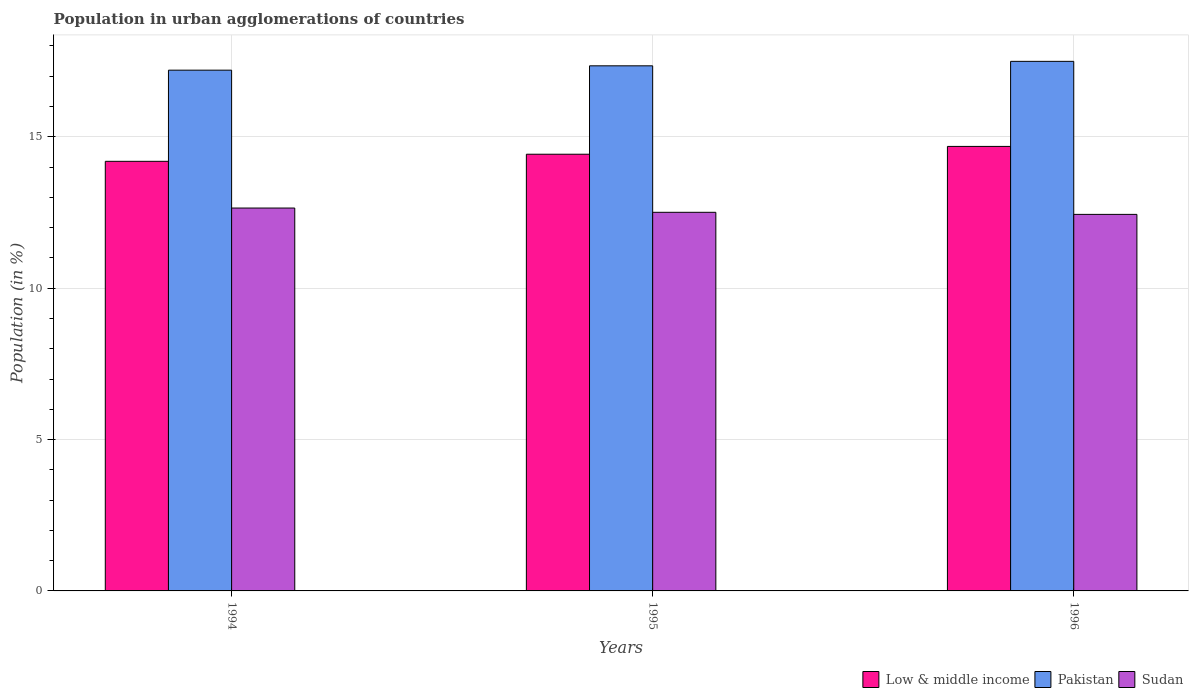How many different coloured bars are there?
Your response must be concise. 3. How many groups of bars are there?
Your answer should be compact. 3. Are the number of bars per tick equal to the number of legend labels?
Your answer should be compact. Yes. Are the number of bars on each tick of the X-axis equal?
Make the answer very short. Yes. How many bars are there on the 2nd tick from the right?
Your response must be concise. 3. What is the label of the 3rd group of bars from the left?
Give a very brief answer. 1996. What is the percentage of population in urban agglomerations in Pakistan in 1996?
Make the answer very short. 17.49. Across all years, what is the maximum percentage of population in urban agglomerations in Pakistan?
Your answer should be compact. 17.49. Across all years, what is the minimum percentage of population in urban agglomerations in Pakistan?
Provide a short and direct response. 17.2. In which year was the percentage of population in urban agglomerations in Pakistan minimum?
Provide a succinct answer. 1994. What is the total percentage of population in urban agglomerations in Low & middle income in the graph?
Give a very brief answer. 43.3. What is the difference between the percentage of population in urban agglomerations in Low & middle income in 1995 and that in 1996?
Keep it short and to the point. -0.26. What is the difference between the percentage of population in urban agglomerations in Low & middle income in 1996 and the percentage of population in urban agglomerations in Pakistan in 1995?
Keep it short and to the point. -2.66. What is the average percentage of population in urban agglomerations in Low & middle income per year?
Your answer should be very brief. 14.43. In the year 1996, what is the difference between the percentage of population in urban agglomerations in Pakistan and percentage of population in urban agglomerations in Low & middle income?
Provide a short and direct response. 2.81. In how many years, is the percentage of population in urban agglomerations in Sudan greater than 14 %?
Keep it short and to the point. 0. What is the ratio of the percentage of population in urban agglomerations in Pakistan in 1995 to that in 1996?
Make the answer very short. 0.99. What is the difference between the highest and the second highest percentage of population in urban agglomerations in Low & middle income?
Provide a short and direct response. 0.26. What is the difference between the highest and the lowest percentage of population in urban agglomerations in Low & middle income?
Keep it short and to the point. 0.49. Is the sum of the percentage of population in urban agglomerations in Low & middle income in 1995 and 1996 greater than the maximum percentage of population in urban agglomerations in Pakistan across all years?
Provide a succinct answer. Yes. What does the 2nd bar from the left in 1996 represents?
Offer a very short reply. Pakistan. What does the 1st bar from the right in 1994 represents?
Keep it short and to the point. Sudan. Is it the case that in every year, the sum of the percentage of population in urban agglomerations in Low & middle income and percentage of population in urban agglomerations in Sudan is greater than the percentage of population in urban agglomerations in Pakistan?
Ensure brevity in your answer.  Yes. How many bars are there?
Give a very brief answer. 9. Are all the bars in the graph horizontal?
Your answer should be compact. No. How many years are there in the graph?
Your response must be concise. 3. Are the values on the major ticks of Y-axis written in scientific E-notation?
Your response must be concise. No. Does the graph contain any zero values?
Offer a terse response. No. How are the legend labels stacked?
Keep it short and to the point. Horizontal. What is the title of the graph?
Offer a terse response. Population in urban agglomerations of countries. What is the label or title of the X-axis?
Keep it short and to the point. Years. What is the Population (in %) in Low & middle income in 1994?
Keep it short and to the point. 14.19. What is the Population (in %) of Pakistan in 1994?
Give a very brief answer. 17.2. What is the Population (in %) of Sudan in 1994?
Make the answer very short. 12.65. What is the Population (in %) of Low & middle income in 1995?
Offer a terse response. 14.43. What is the Population (in %) of Pakistan in 1995?
Your response must be concise. 17.35. What is the Population (in %) of Sudan in 1995?
Ensure brevity in your answer.  12.51. What is the Population (in %) of Low & middle income in 1996?
Make the answer very short. 14.68. What is the Population (in %) of Pakistan in 1996?
Provide a succinct answer. 17.49. What is the Population (in %) of Sudan in 1996?
Your answer should be compact. 12.44. Across all years, what is the maximum Population (in %) of Low & middle income?
Give a very brief answer. 14.68. Across all years, what is the maximum Population (in %) of Pakistan?
Give a very brief answer. 17.49. Across all years, what is the maximum Population (in %) of Sudan?
Your response must be concise. 12.65. Across all years, what is the minimum Population (in %) in Low & middle income?
Keep it short and to the point. 14.19. Across all years, what is the minimum Population (in %) in Pakistan?
Offer a terse response. 17.2. Across all years, what is the minimum Population (in %) of Sudan?
Offer a very short reply. 12.44. What is the total Population (in %) in Low & middle income in the graph?
Give a very brief answer. 43.3. What is the total Population (in %) in Pakistan in the graph?
Provide a succinct answer. 52.04. What is the total Population (in %) of Sudan in the graph?
Give a very brief answer. 37.59. What is the difference between the Population (in %) of Low & middle income in 1994 and that in 1995?
Offer a very short reply. -0.23. What is the difference between the Population (in %) of Pakistan in 1994 and that in 1995?
Give a very brief answer. -0.14. What is the difference between the Population (in %) in Sudan in 1994 and that in 1995?
Your answer should be very brief. 0.14. What is the difference between the Population (in %) of Low & middle income in 1994 and that in 1996?
Keep it short and to the point. -0.49. What is the difference between the Population (in %) in Pakistan in 1994 and that in 1996?
Provide a succinct answer. -0.29. What is the difference between the Population (in %) of Sudan in 1994 and that in 1996?
Make the answer very short. 0.21. What is the difference between the Population (in %) in Low & middle income in 1995 and that in 1996?
Your answer should be very brief. -0.26. What is the difference between the Population (in %) of Pakistan in 1995 and that in 1996?
Make the answer very short. -0.15. What is the difference between the Population (in %) in Sudan in 1995 and that in 1996?
Offer a terse response. 0.07. What is the difference between the Population (in %) in Low & middle income in 1994 and the Population (in %) in Pakistan in 1995?
Give a very brief answer. -3.15. What is the difference between the Population (in %) in Low & middle income in 1994 and the Population (in %) in Sudan in 1995?
Offer a very short reply. 1.68. What is the difference between the Population (in %) in Pakistan in 1994 and the Population (in %) in Sudan in 1995?
Offer a terse response. 4.7. What is the difference between the Population (in %) in Low & middle income in 1994 and the Population (in %) in Pakistan in 1996?
Make the answer very short. -3.3. What is the difference between the Population (in %) in Low & middle income in 1994 and the Population (in %) in Sudan in 1996?
Keep it short and to the point. 1.75. What is the difference between the Population (in %) in Pakistan in 1994 and the Population (in %) in Sudan in 1996?
Your answer should be compact. 4.76. What is the difference between the Population (in %) of Low & middle income in 1995 and the Population (in %) of Pakistan in 1996?
Ensure brevity in your answer.  -3.07. What is the difference between the Population (in %) of Low & middle income in 1995 and the Population (in %) of Sudan in 1996?
Offer a terse response. 1.99. What is the difference between the Population (in %) in Pakistan in 1995 and the Population (in %) in Sudan in 1996?
Provide a succinct answer. 4.91. What is the average Population (in %) of Low & middle income per year?
Provide a short and direct response. 14.43. What is the average Population (in %) in Pakistan per year?
Ensure brevity in your answer.  17.35. What is the average Population (in %) of Sudan per year?
Keep it short and to the point. 12.53. In the year 1994, what is the difference between the Population (in %) of Low & middle income and Population (in %) of Pakistan?
Your response must be concise. -3.01. In the year 1994, what is the difference between the Population (in %) in Low & middle income and Population (in %) in Sudan?
Offer a terse response. 1.54. In the year 1994, what is the difference between the Population (in %) of Pakistan and Population (in %) of Sudan?
Make the answer very short. 4.55. In the year 1995, what is the difference between the Population (in %) of Low & middle income and Population (in %) of Pakistan?
Your response must be concise. -2.92. In the year 1995, what is the difference between the Population (in %) of Low & middle income and Population (in %) of Sudan?
Provide a short and direct response. 1.92. In the year 1995, what is the difference between the Population (in %) in Pakistan and Population (in %) in Sudan?
Provide a short and direct response. 4.84. In the year 1996, what is the difference between the Population (in %) in Low & middle income and Population (in %) in Pakistan?
Give a very brief answer. -2.81. In the year 1996, what is the difference between the Population (in %) of Low & middle income and Population (in %) of Sudan?
Your answer should be very brief. 2.25. In the year 1996, what is the difference between the Population (in %) of Pakistan and Population (in %) of Sudan?
Make the answer very short. 5.05. What is the ratio of the Population (in %) of Low & middle income in 1994 to that in 1995?
Make the answer very short. 0.98. What is the ratio of the Population (in %) in Sudan in 1994 to that in 1995?
Provide a short and direct response. 1.01. What is the ratio of the Population (in %) of Low & middle income in 1994 to that in 1996?
Provide a succinct answer. 0.97. What is the ratio of the Population (in %) of Pakistan in 1994 to that in 1996?
Ensure brevity in your answer.  0.98. What is the ratio of the Population (in %) in Sudan in 1994 to that in 1996?
Provide a short and direct response. 1.02. What is the ratio of the Population (in %) in Low & middle income in 1995 to that in 1996?
Your answer should be compact. 0.98. What is the ratio of the Population (in %) of Sudan in 1995 to that in 1996?
Offer a terse response. 1.01. What is the difference between the highest and the second highest Population (in %) of Low & middle income?
Give a very brief answer. 0.26. What is the difference between the highest and the second highest Population (in %) in Pakistan?
Give a very brief answer. 0.15. What is the difference between the highest and the second highest Population (in %) of Sudan?
Your answer should be very brief. 0.14. What is the difference between the highest and the lowest Population (in %) of Low & middle income?
Offer a very short reply. 0.49. What is the difference between the highest and the lowest Population (in %) of Pakistan?
Your response must be concise. 0.29. What is the difference between the highest and the lowest Population (in %) in Sudan?
Give a very brief answer. 0.21. 